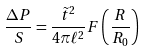Convert formula to latex. <formula><loc_0><loc_0><loc_500><loc_500>\frac { \Delta P } { S } = \frac { \tilde { t } ^ { 2 } } { 4 \pi \ell ^ { 2 } } F \left ( \frac { R } { R _ { 0 } } \right )</formula> 